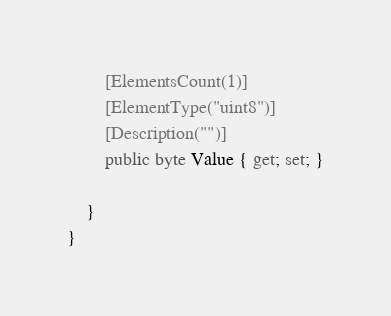<code> <loc_0><loc_0><loc_500><loc_500><_C#_>        [ElementsCount(1)]
        [ElementType("uint8")]
        [Description("")]
        public byte Value { get; set; }
        
    }
}
</code> 